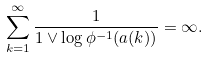Convert formula to latex. <formula><loc_0><loc_0><loc_500><loc_500>\sum _ { k = 1 } ^ { \infty } \frac { 1 } { 1 \vee \log \phi ^ { - 1 } ( a ( k ) ) } = \infty .</formula> 